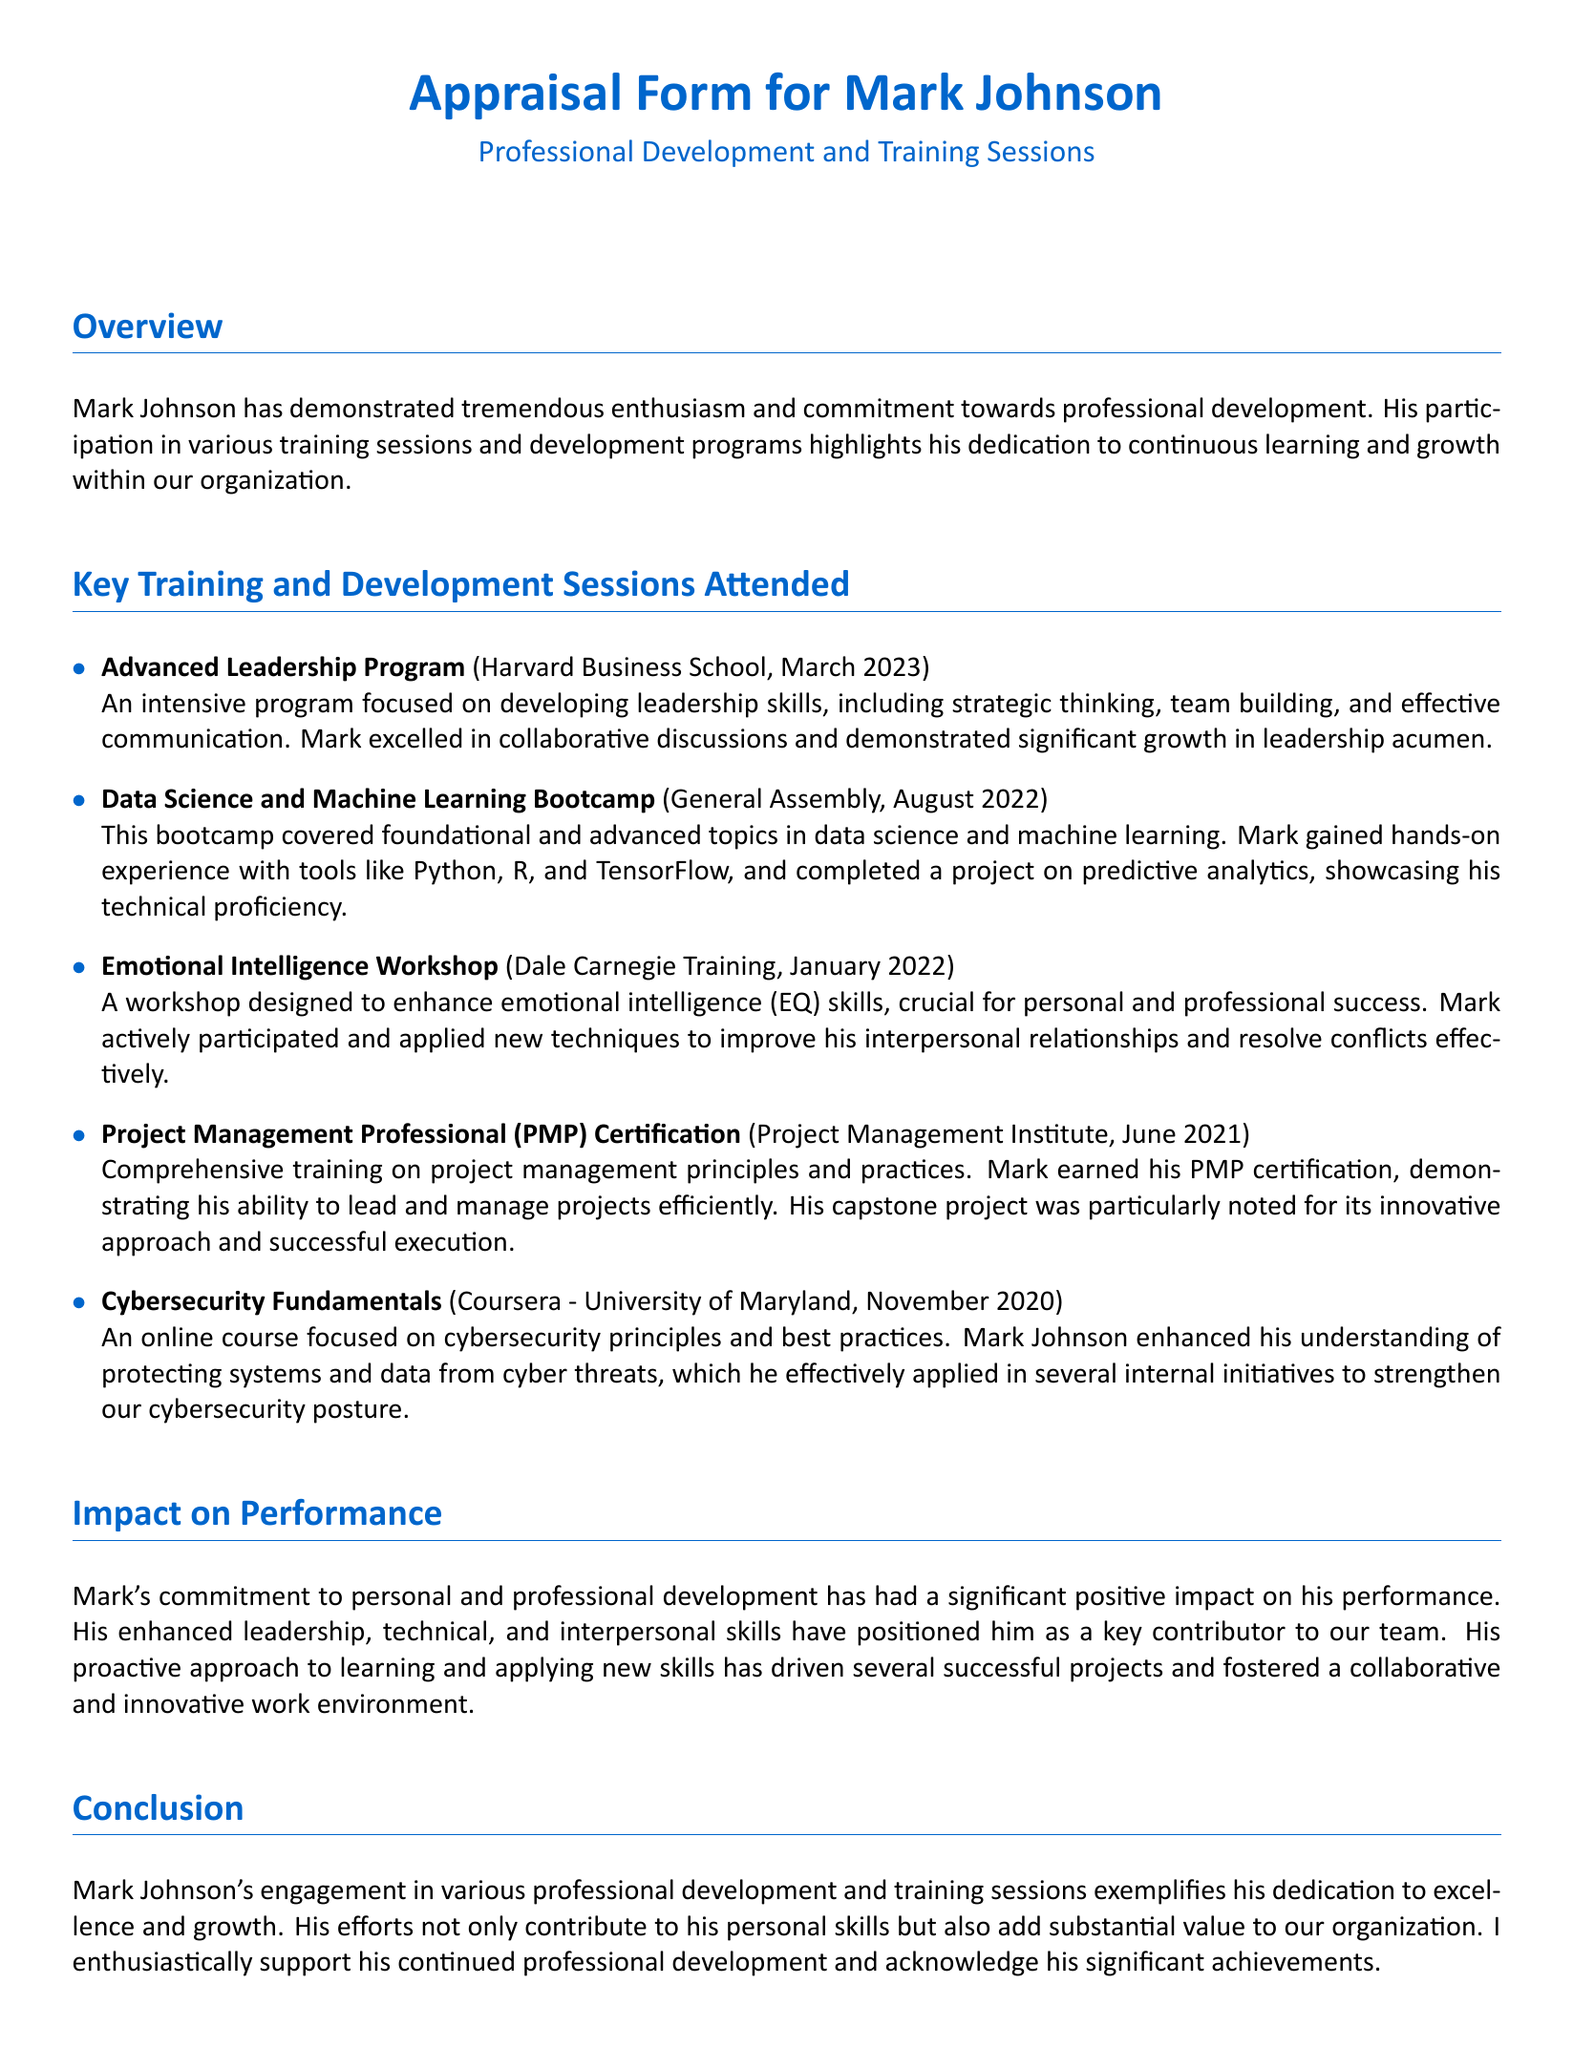what is the title of the appraisal form? The title of the appraisal form is explicitly stated at the beginning of the document as "Appraisal Form for Mark Johnson".
Answer: Appraisal Form for Mark Johnson which training program did Mark attend in March 2023? The document lists the specific training Mark attended in March 2023, which is the "Advanced Leadership Program" at Harvard Business School.
Answer: Advanced Leadership Program how many training sessions are listed in the document? The document outlines five distinct training sessions attended by Mark Johnson, as indicated in the "Key Training and Development Sessions Attended" section.
Answer: Five what is the focus of the Emotional Intelligence Workshop? The document describes the focus of the Emotional Intelligence Workshop as enhancing emotional intelligence (EQ) skills.
Answer: Emotional intelligence (EQ) skills which certification did Mark earn in June 2021? The document states that Mark earned the "Project Management Professional (PMP) Certification" in June 2021.
Answer: Project Management Professional (PMP) Certification how has Mark's training impacted his performance? The impact of Mark's training on his performance is highlighted as significant and positive, contributing key skills and fostering a collaborative work environment.
Answer: Significant and positive impact what was the capstone project noted for? The document states that Mark's capstone project for his PMP certification was particularly noted for its innovative approach and successful execution.
Answer: Innovative approach and successful execution what type of training did Mark receive from Coursera? According to the document, Mark received training in "Cybersecurity Fundamentals" from Coursera.
Answer: Cybersecurity Fundamentals how many months passed between the Data Science and Machine Learning Bootcamp and the Advanced Leadership Program? The Data Science and Machine Learning Bootcamp occurred in August 2022, and the Advanced Leadership Program was in March 2023, resulting in seven months between the two programs.
Answer: Seven months 